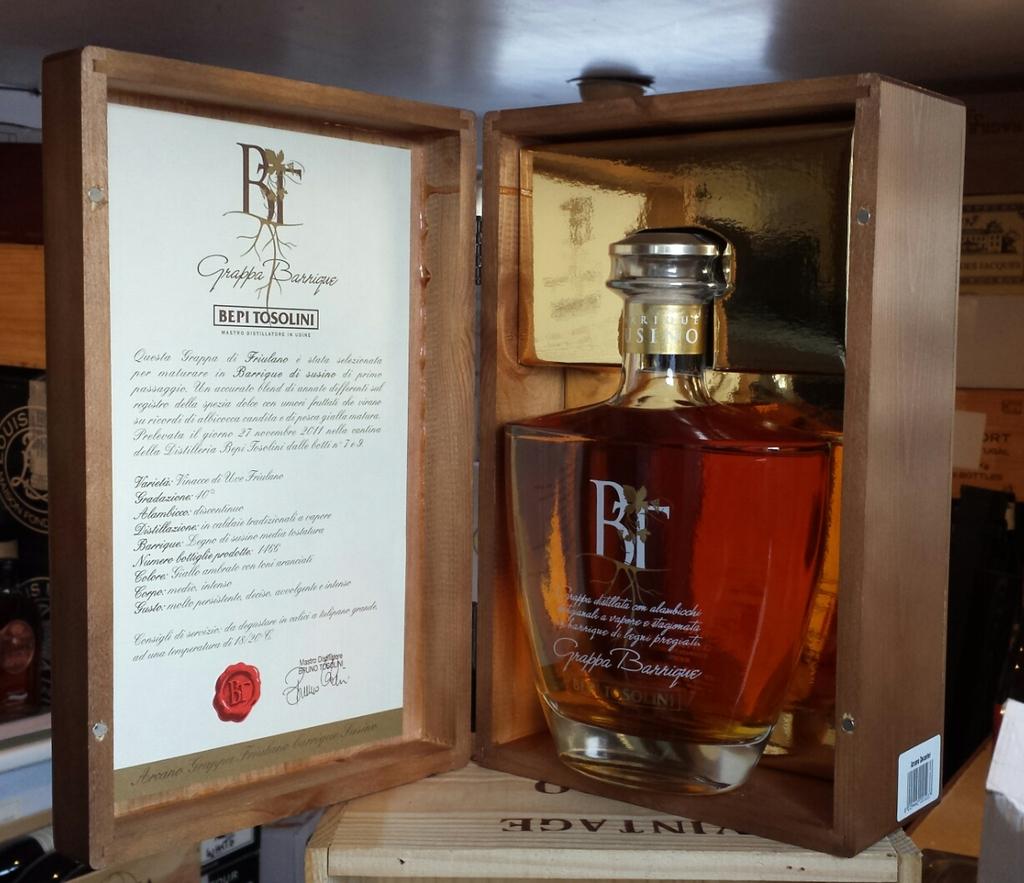What is the brand on the bottle?
Offer a very short reply. Bt. 